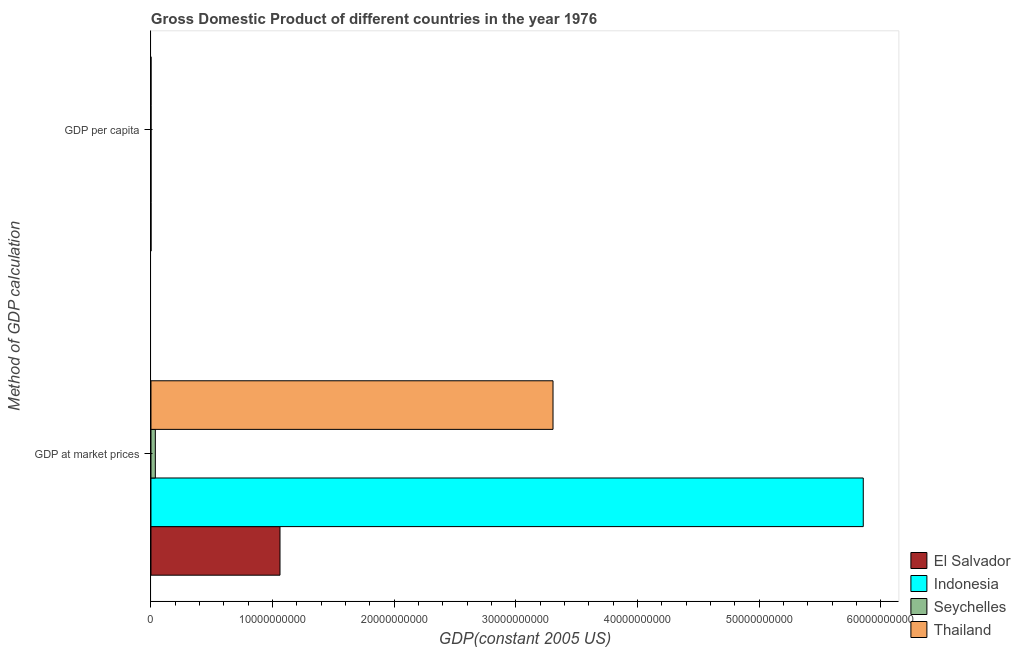How many different coloured bars are there?
Provide a short and direct response. 4. Are the number of bars per tick equal to the number of legend labels?
Your answer should be very brief. Yes. Are the number of bars on each tick of the Y-axis equal?
Keep it short and to the point. Yes. What is the label of the 1st group of bars from the top?
Offer a terse response. GDP per capita. What is the gdp per capita in Seychelles?
Give a very brief answer. 5941.32. Across all countries, what is the maximum gdp at market prices?
Keep it short and to the point. 5.86e+1. Across all countries, what is the minimum gdp per capita?
Keep it short and to the point. 436.93. In which country was the gdp at market prices maximum?
Keep it short and to the point. Indonesia. What is the total gdp at market prices in the graph?
Offer a terse response. 1.03e+11. What is the difference between the gdp per capita in Seychelles and that in Indonesia?
Give a very brief answer. 5504.39. What is the difference between the gdp at market prices in Seychelles and the gdp per capita in Thailand?
Your answer should be very brief. 3.61e+08. What is the average gdp per capita per country?
Offer a terse response. 2410.58. What is the difference between the gdp per capita and gdp at market prices in Thailand?
Make the answer very short. -3.31e+1. What is the ratio of the gdp at market prices in Thailand to that in Seychelles?
Your response must be concise. 91.64. Is the gdp at market prices in Thailand less than that in Indonesia?
Your response must be concise. Yes. In how many countries, is the gdp per capita greater than the average gdp per capita taken over all countries?
Offer a terse response. 2. What does the 2nd bar from the top in GDP at market prices represents?
Provide a short and direct response. Seychelles. What does the 2nd bar from the bottom in GDP at market prices represents?
Offer a very short reply. Indonesia. Are all the bars in the graph horizontal?
Your answer should be very brief. Yes. How many countries are there in the graph?
Provide a short and direct response. 4. What is the difference between two consecutive major ticks on the X-axis?
Make the answer very short. 1.00e+1. Are the values on the major ticks of X-axis written in scientific E-notation?
Your response must be concise. No. Does the graph contain any zero values?
Your answer should be very brief. No. Where does the legend appear in the graph?
Offer a very short reply. Bottom right. How many legend labels are there?
Offer a terse response. 4. What is the title of the graph?
Your answer should be very brief. Gross Domestic Product of different countries in the year 1976. Does "South Africa" appear as one of the legend labels in the graph?
Offer a terse response. No. What is the label or title of the X-axis?
Keep it short and to the point. GDP(constant 2005 US). What is the label or title of the Y-axis?
Your answer should be very brief. Method of GDP calculation. What is the GDP(constant 2005 US) in El Salvador in GDP at market prices?
Offer a terse response. 1.06e+1. What is the GDP(constant 2005 US) of Indonesia in GDP at market prices?
Your answer should be compact. 5.86e+1. What is the GDP(constant 2005 US) of Seychelles in GDP at market prices?
Provide a short and direct response. 3.61e+08. What is the GDP(constant 2005 US) of Thailand in GDP at market prices?
Your answer should be compact. 3.31e+1. What is the GDP(constant 2005 US) of El Salvador in GDP per capita?
Offer a terse response. 2502.29. What is the GDP(constant 2005 US) in Indonesia in GDP per capita?
Make the answer very short. 436.93. What is the GDP(constant 2005 US) in Seychelles in GDP per capita?
Ensure brevity in your answer.  5941.32. What is the GDP(constant 2005 US) of Thailand in GDP per capita?
Provide a succinct answer. 761.76. Across all Method of GDP calculation, what is the maximum GDP(constant 2005 US) of El Salvador?
Ensure brevity in your answer.  1.06e+1. Across all Method of GDP calculation, what is the maximum GDP(constant 2005 US) in Indonesia?
Offer a terse response. 5.86e+1. Across all Method of GDP calculation, what is the maximum GDP(constant 2005 US) in Seychelles?
Your answer should be very brief. 3.61e+08. Across all Method of GDP calculation, what is the maximum GDP(constant 2005 US) of Thailand?
Your answer should be compact. 3.31e+1. Across all Method of GDP calculation, what is the minimum GDP(constant 2005 US) in El Salvador?
Make the answer very short. 2502.29. Across all Method of GDP calculation, what is the minimum GDP(constant 2005 US) of Indonesia?
Keep it short and to the point. 436.93. Across all Method of GDP calculation, what is the minimum GDP(constant 2005 US) in Seychelles?
Your answer should be very brief. 5941.32. Across all Method of GDP calculation, what is the minimum GDP(constant 2005 US) of Thailand?
Give a very brief answer. 761.76. What is the total GDP(constant 2005 US) in El Salvador in the graph?
Your response must be concise. 1.06e+1. What is the total GDP(constant 2005 US) in Indonesia in the graph?
Your answer should be very brief. 5.86e+1. What is the total GDP(constant 2005 US) in Seychelles in the graph?
Provide a succinct answer. 3.61e+08. What is the total GDP(constant 2005 US) in Thailand in the graph?
Provide a short and direct response. 3.31e+1. What is the difference between the GDP(constant 2005 US) in El Salvador in GDP at market prices and that in GDP per capita?
Offer a very short reply. 1.06e+1. What is the difference between the GDP(constant 2005 US) of Indonesia in GDP at market prices and that in GDP per capita?
Provide a short and direct response. 5.86e+1. What is the difference between the GDP(constant 2005 US) in Seychelles in GDP at market prices and that in GDP per capita?
Give a very brief answer. 3.61e+08. What is the difference between the GDP(constant 2005 US) of Thailand in GDP at market prices and that in GDP per capita?
Your response must be concise. 3.31e+1. What is the difference between the GDP(constant 2005 US) in El Salvador in GDP at market prices and the GDP(constant 2005 US) in Indonesia in GDP per capita?
Ensure brevity in your answer.  1.06e+1. What is the difference between the GDP(constant 2005 US) of El Salvador in GDP at market prices and the GDP(constant 2005 US) of Seychelles in GDP per capita?
Make the answer very short. 1.06e+1. What is the difference between the GDP(constant 2005 US) of El Salvador in GDP at market prices and the GDP(constant 2005 US) of Thailand in GDP per capita?
Provide a succinct answer. 1.06e+1. What is the difference between the GDP(constant 2005 US) in Indonesia in GDP at market prices and the GDP(constant 2005 US) in Seychelles in GDP per capita?
Your response must be concise. 5.86e+1. What is the difference between the GDP(constant 2005 US) of Indonesia in GDP at market prices and the GDP(constant 2005 US) of Thailand in GDP per capita?
Your answer should be very brief. 5.86e+1. What is the difference between the GDP(constant 2005 US) of Seychelles in GDP at market prices and the GDP(constant 2005 US) of Thailand in GDP per capita?
Give a very brief answer. 3.61e+08. What is the average GDP(constant 2005 US) in El Salvador per Method of GDP calculation?
Provide a succinct answer. 5.30e+09. What is the average GDP(constant 2005 US) of Indonesia per Method of GDP calculation?
Keep it short and to the point. 2.93e+1. What is the average GDP(constant 2005 US) of Seychelles per Method of GDP calculation?
Provide a short and direct response. 1.80e+08. What is the average GDP(constant 2005 US) in Thailand per Method of GDP calculation?
Offer a very short reply. 1.65e+1. What is the difference between the GDP(constant 2005 US) of El Salvador and GDP(constant 2005 US) of Indonesia in GDP at market prices?
Give a very brief answer. -4.79e+1. What is the difference between the GDP(constant 2005 US) of El Salvador and GDP(constant 2005 US) of Seychelles in GDP at market prices?
Offer a terse response. 1.02e+1. What is the difference between the GDP(constant 2005 US) of El Salvador and GDP(constant 2005 US) of Thailand in GDP at market prices?
Ensure brevity in your answer.  -2.24e+1. What is the difference between the GDP(constant 2005 US) in Indonesia and GDP(constant 2005 US) in Seychelles in GDP at market prices?
Provide a succinct answer. 5.82e+1. What is the difference between the GDP(constant 2005 US) of Indonesia and GDP(constant 2005 US) of Thailand in GDP at market prices?
Your answer should be very brief. 2.55e+1. What is the difference between the GDP(constant 2005 US) of Seychelles and GDP(constant 2005 US) of Thailand in GDP at market prices?
Your response must be concise. -3.27e+1. What is the difference between the GDP(constant 2005 US) in El Salvador and GDP(constant 2005 US) in Indonesia in GDP per capita?
Ensure brevity in your answer.  2065.35. What is the difference between the GDP(constant 2005 US) in El Salvador and GDP(constant 2005 US) in Seychelles in GDP per capita?
Your response must be concise. -3439.04. What is the difference between the GDP(constant 2005 US) in El Salvador and GDP(constant 2005 US) in Thailand in GDP per capita?
Offer a very short reply. 1740.52. What is the difference between the GDP(constant 2005 US) in Indonesia and GDP(constant 2005 US) in Seychelles in GDP per capita?
Ensure brevity in your answer.  -5504.39. What is the difference between the GDP(constant 2005 US) of Indonesia and GDP(constant 2005 US) of Thailand in GDP per capita?
Keep it short and to the point. -324.83. What is the difference between the GDP(constant 2005 US) of Seychelles and GDP(constant 2005 US) of Thailand in GDP per capita?
Ensure brevity in your answer.  5179.56. What is the ratio of the GDP(constant 2005 US) in El Salvador in GDP at market prices to that in GDP per capita?
Keep it short and to the point. 4.24e+06. What is the ratio of the GDP(constant 2005 US) of Indonesia in GDP at market prices to that in GDP per capita?
Your answer should be compact. 1.34e+08. What is the ratio of the GDP(constant 2005 US) in Seychelles in GDP at market prices to that in GDP per capita?
Your response must be concise. 6.07e+04. What is the ratio of the GDP(constant 2005 US) of Thailand in GDP at market prices to that in GDP per capita?
Your answer should be very brief. 4.34e+07. What is the difference between the highest and the second highest GDP(constant 2005 US) of El Salvador?
Your response must be concise. 1.06e+1. What is the difference between the highest and the second highest GDP(constant 2005 US) of Indonesia?
Provide a short and direct response. 5.86e+1. What is the difference between the highest and the second highest GDP(constant 2005 US) in Seychelles?
Make the answer very short. 3.61e+08. What is the difference between the highest and the second highest GDP(constant 2005 US) in Thailand?
Provide a short and direct response. 3.31e+1. What is the difference between the highest and the lowest GDP(constant 2005 US) of El Salvador?
Provide a succinct answer. 1.06e+1. What is the difference between the highest and the lowest GDP(constant 2005 US) of Indonesia?
Your response must be concise. 5.86e+1. What is the difference between the highest and the lowest GDP(constant 2005 US) in Seychelles?
Give a very brief answer. 3.61e+08. What is the difference between the highest and the lowest GDP(constant 2005 US) in Thailand?
Your answer should be very brief. 3.31e+1. 